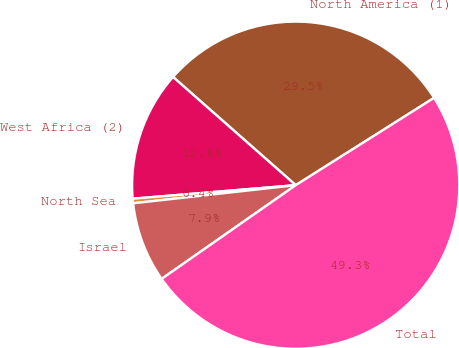Convert chart. <chart><loc_0><loc_0><loc_500><loc_500><pie_chart><fcel>North America (1)<fcel>West Africa (2)<fcel>North Sea<fcel>Israel<fcel>Total<nl><fcel>29.54%<fcel>12.82%<fcel>0.45%<fcel>7.94%<fcel>49.26%<nl></chart> 